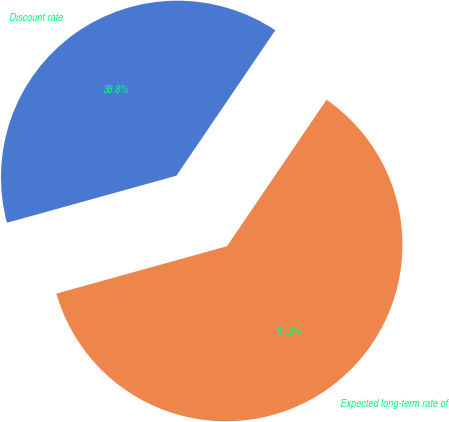Convert chart. <chart><loc_0><loc_0><loc_500><loc_500><pie_chart><fcel>Discount rate<fcel>Expected long-term rate of<nl><fcel>38.81%<fcel>61.19%<nl></chart> 